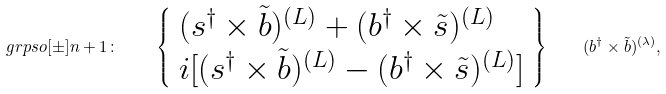<formula> <loc_0><loc_0><loc_500><loc_500>\ g r p s o [ \pm ] { n + 1 } \colon \quad \left \{ \begin{array} { l } ( s ^ { \dagger } \times \tilde { b } ) ^ { ( L ) } + ( b ^ { \dagger } \times \tilde { s } ) ^ { ( L ) } \\ i [ ( s ^ { \dagger } \times \tilde { b } ) ^ { ( L ) } - ( b ^ { \dagger } \times \tilde { s } ) ^ { ( L ) } ] \end{array} \right \} \quad ( b ^ { \dagger } \times \tilde { b } ) ^ { ( \lambda ) } ,</formula> 